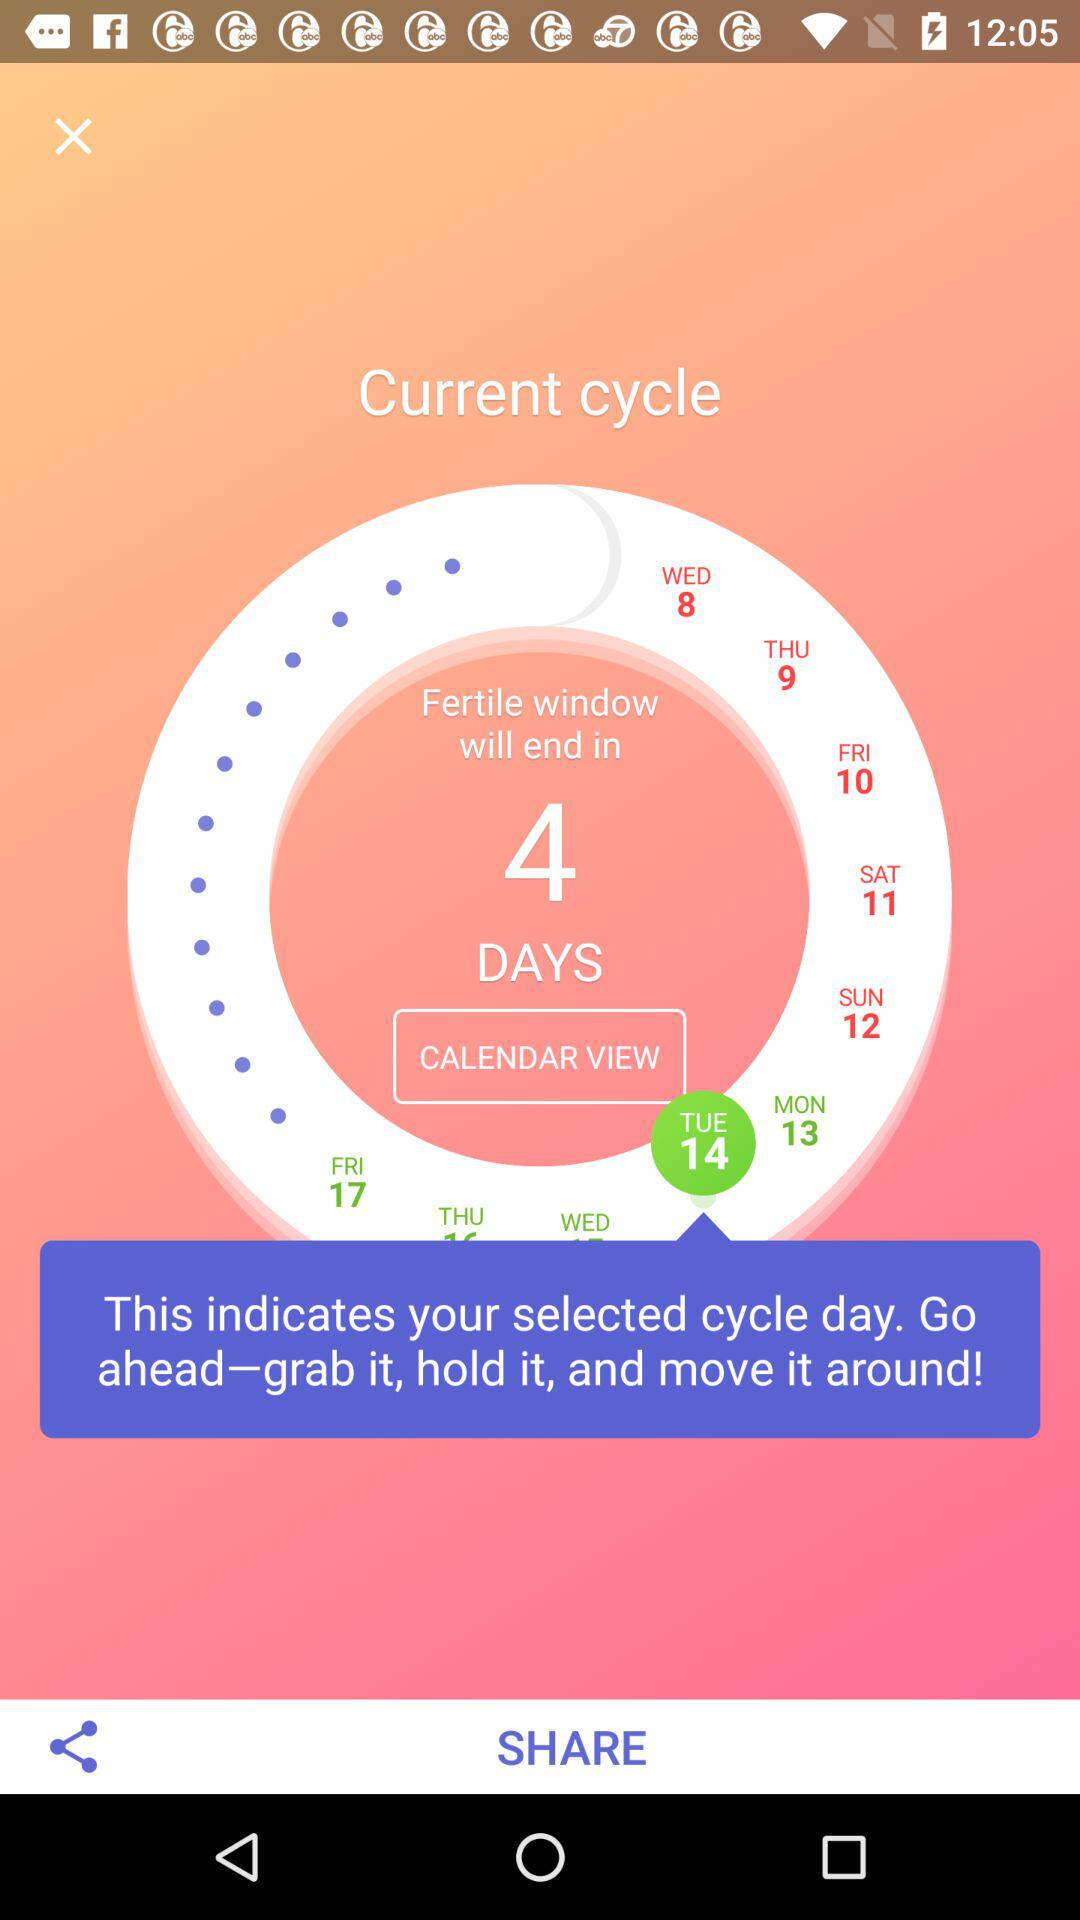Which day of the week is the fertile window ending on?
Answer the question using a single word or phrase. Friday 